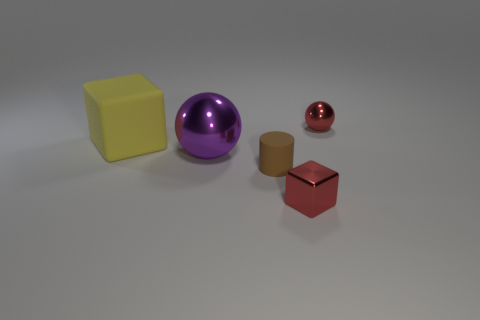Add 1 tiny green metallic balls. How many objects exist? 6 Subtract all blocks. How many objects are left? 3 Add 1 metal balls. How many metal balls are left? 3 Add 3 red cubes. How many red cubes exist? 4 Subtract 0 gray spheres. How many objects are left? 5 Subtract all shiny things. Subtract all small rubber things. How many objects are left? 1 